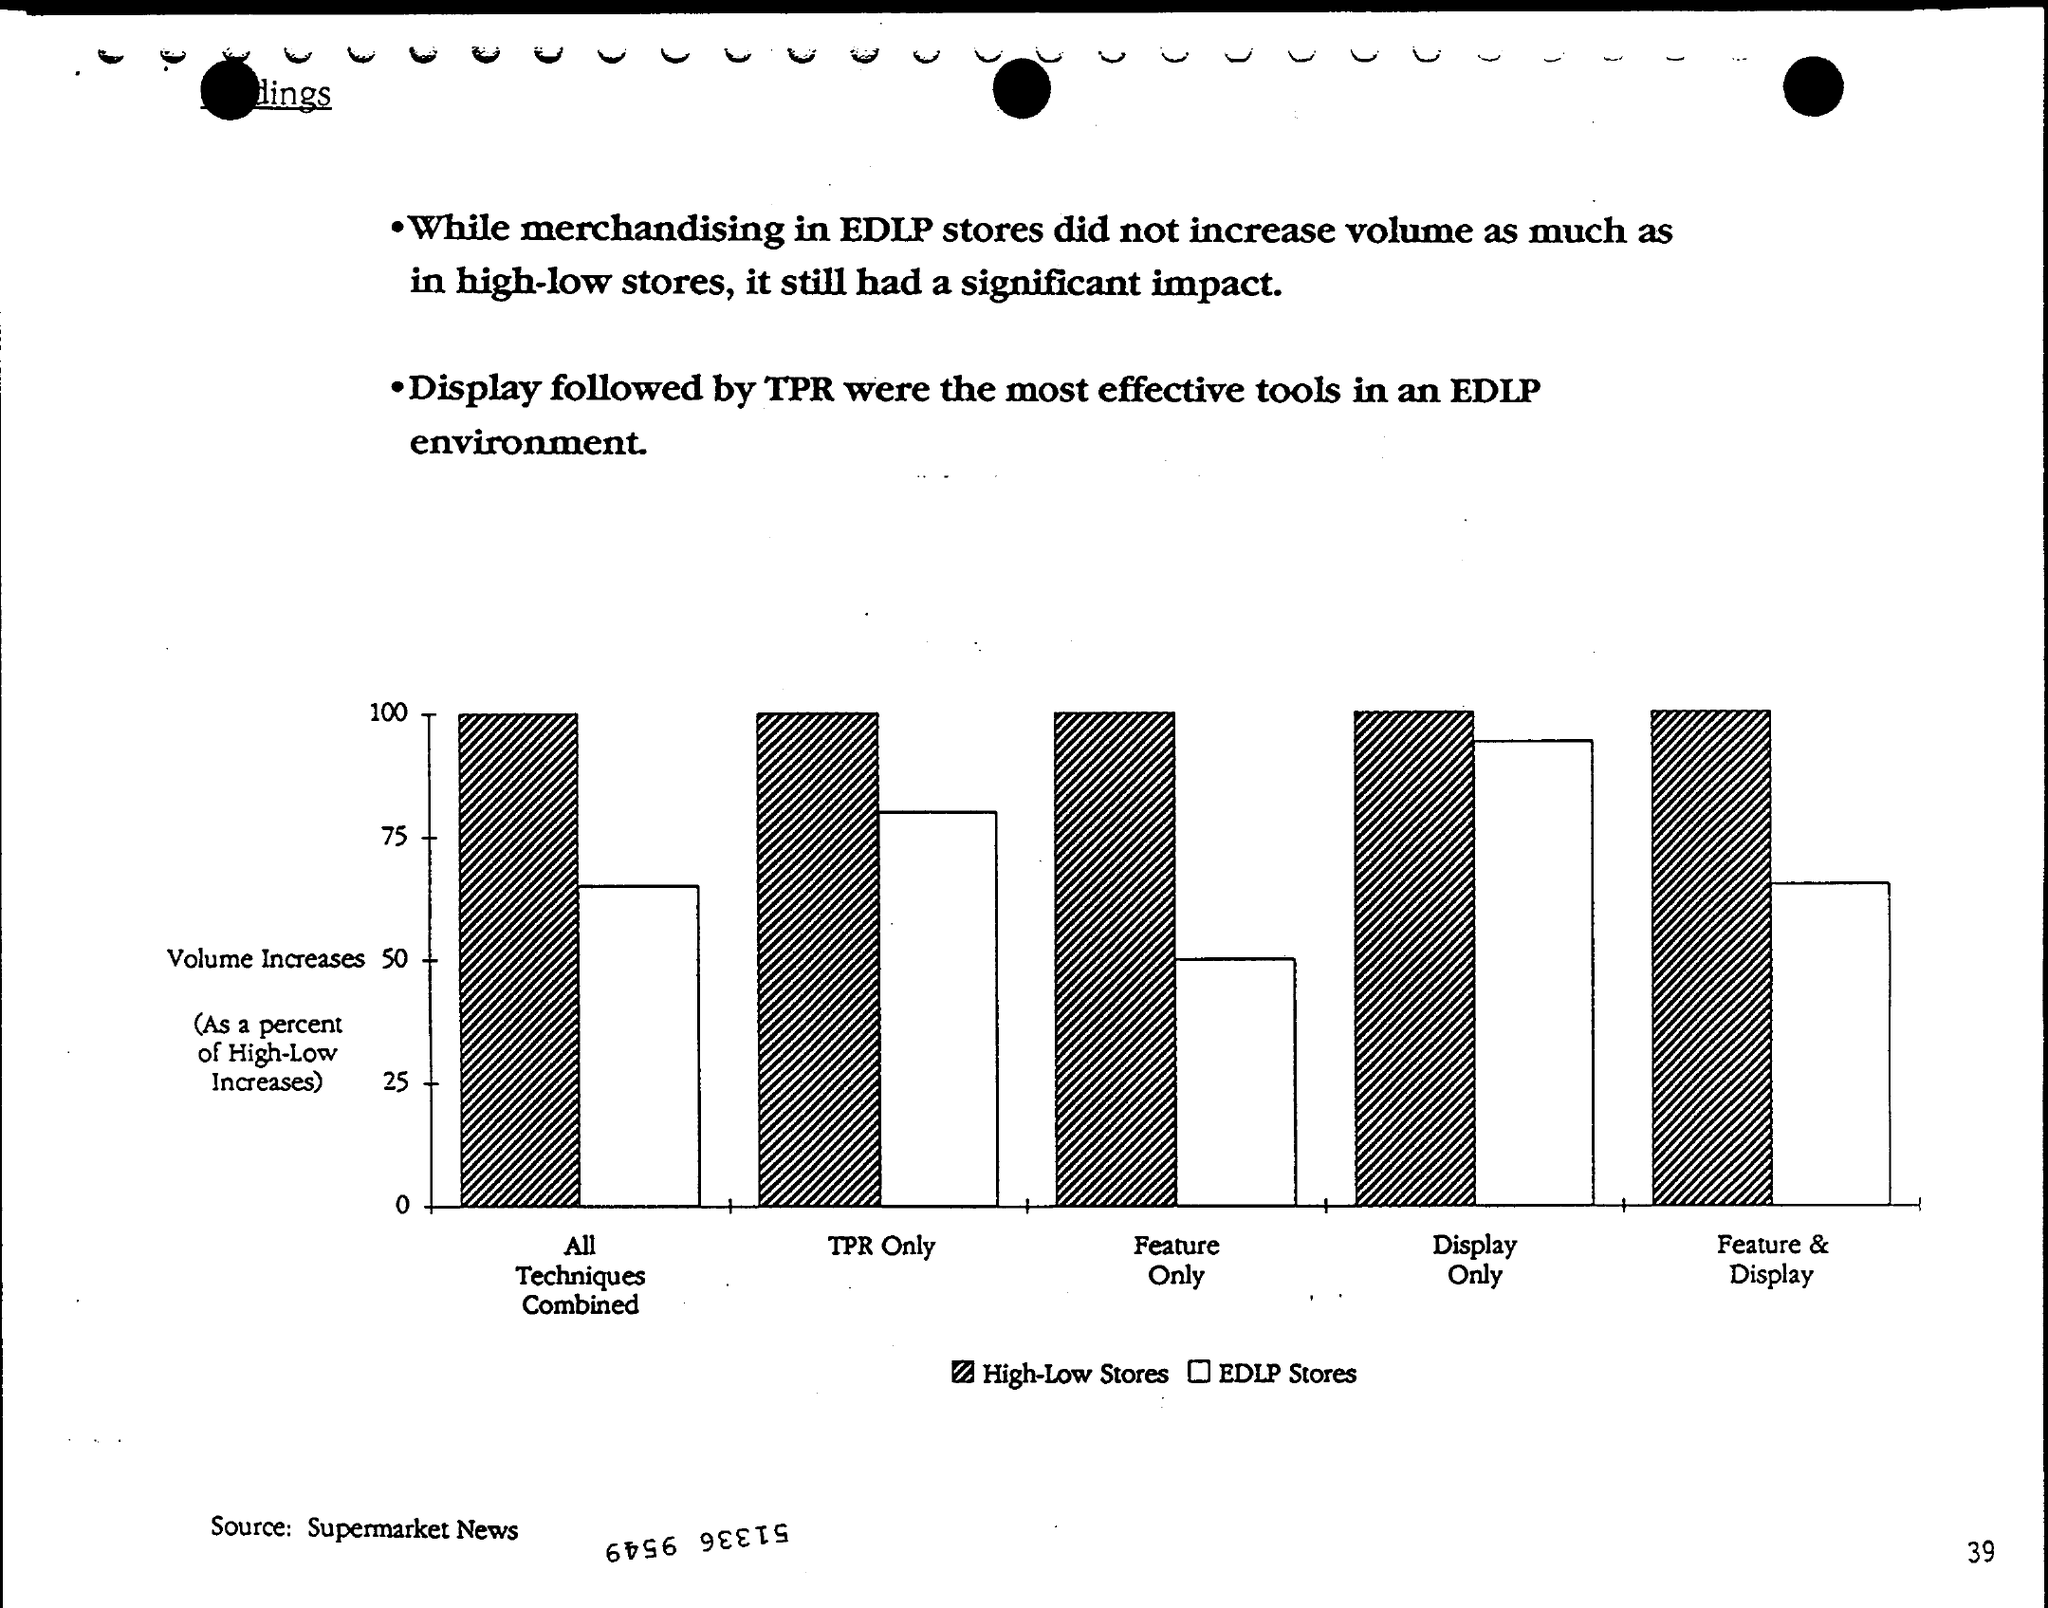Mention a couple of crucial points in this snapshot. The Source is Supermarket News. 